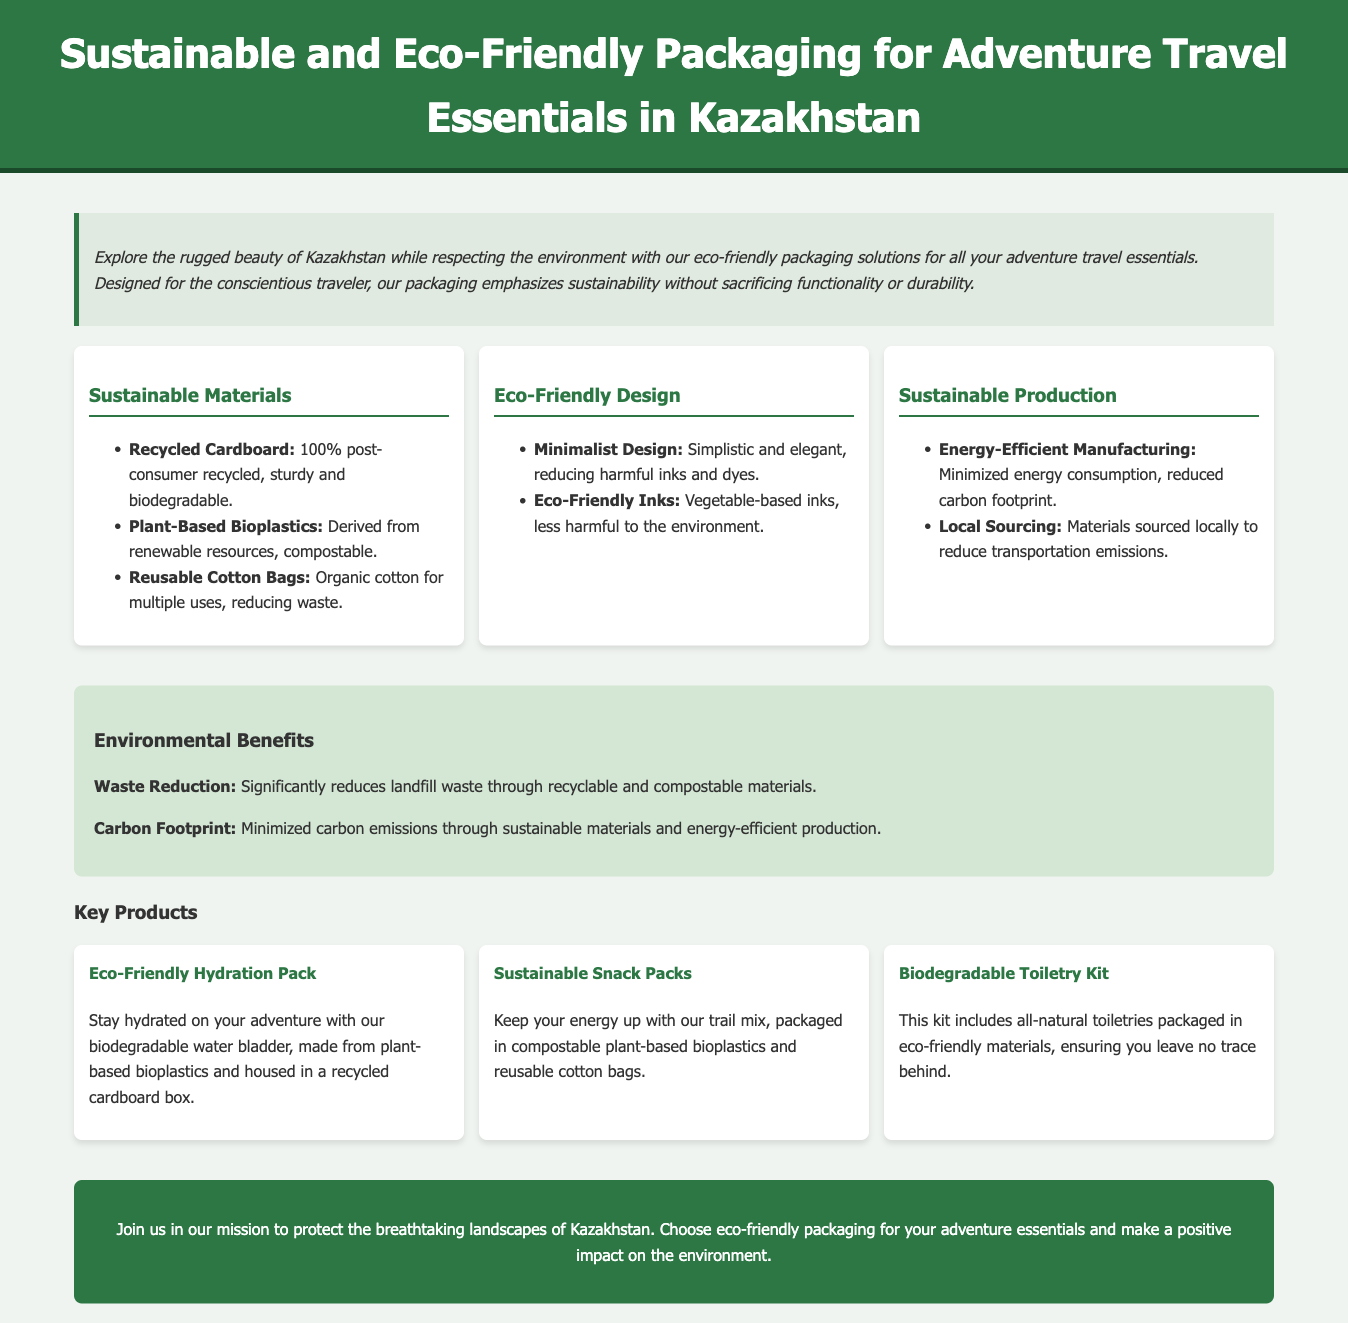what materials are used for eco-friendly packaging? The document lists recycled cardboard, plant-based bioplastics, and reusable cotton bags as the sustainable materials used for eco-friendly packaging.
Answer: recycled cardboard, plant-based bioplastics, reusable cotton bags what type of design is emphasized in the packaging? The document states that the design is minimalist, focusing on simplicity and reducing harmful inks and dyes.
Answer: Minimalist Design what is a benefit of using eco-friendly inks? The document mentions that eco-friendly inks are vegetable-based and less harmful to the environment.
Answer: Less harmful to the environment how do sustainable packaging solutions contribute to waste reduction? The document indicates that using recyclable and compostable materials significantly reduces landfill waste.
Answer: Reduces landfill waste what is one key product mentioned in the document? The document lists several key products, including the Eco-Friendly Hydration Pack, Sustainable Snack Packs, or Biodegradable Toiletry Kit.
Answer: Eco-Friendly Hydration Pack how does local sourcing affect the packaging production? The document highlights that local sourcing reduces transportation emissions, contributing to more sustainable production practices.
Answer: Reduces transportation emissions how does the biodegradable water bladder benefit adventurers? The document states that it is made from plant-based bioplastics, making it environmentally friendly.
Answer: Environmentally friendly what message does the customer segment convey? The document communicates a message to join in the mission of protecting the environment through eco-friendly choices.
Answer: Protect the environment 